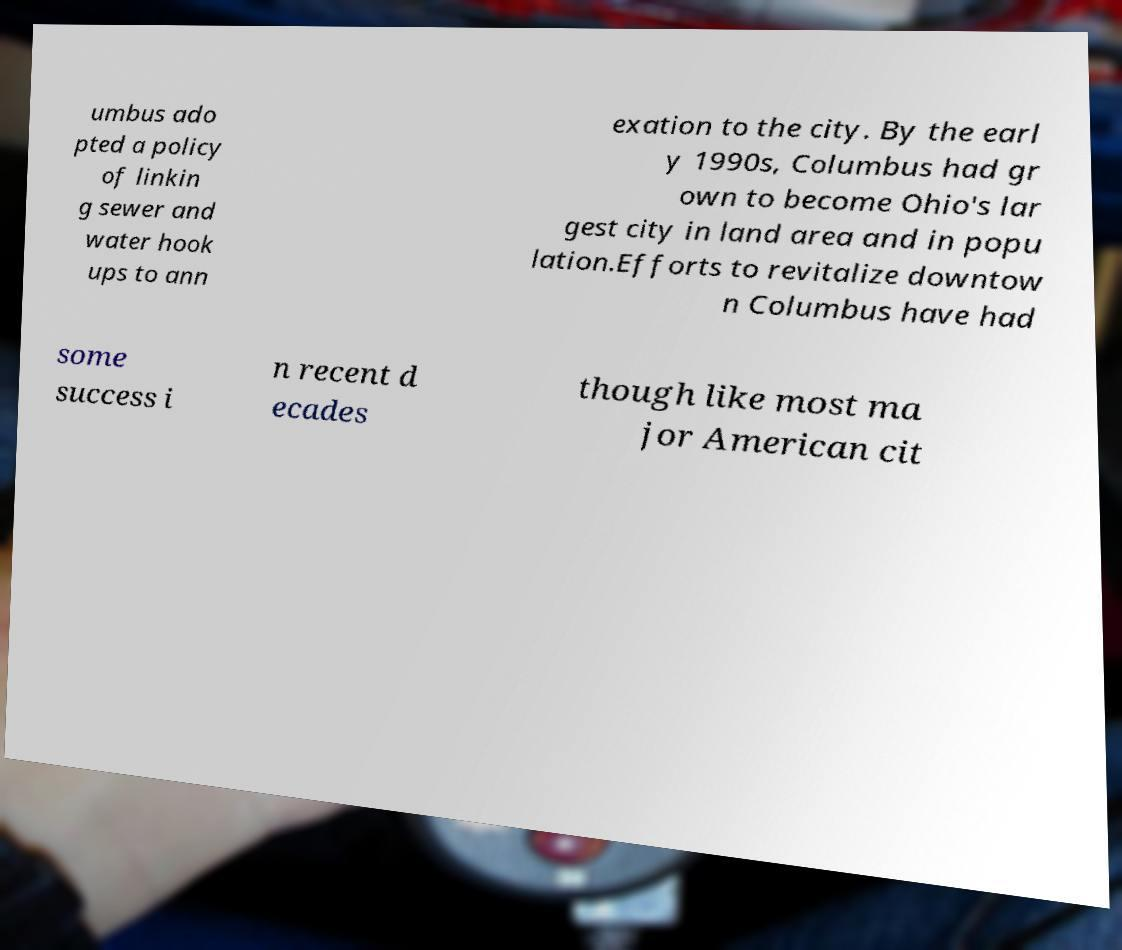There's text embedded in this image that I need extracted. Can you transcribe it verbatim? umbus ado pted a policy of linkin g sewer and water hook ups to ann exation to the city. By the earl y 1990s, Columbus had gr own to become Ohio's lar gest city in land area and in popu lation.Efforts to revitalize downtow n Columbus have had some success i n recent d ecades though like most ma jor American cit 